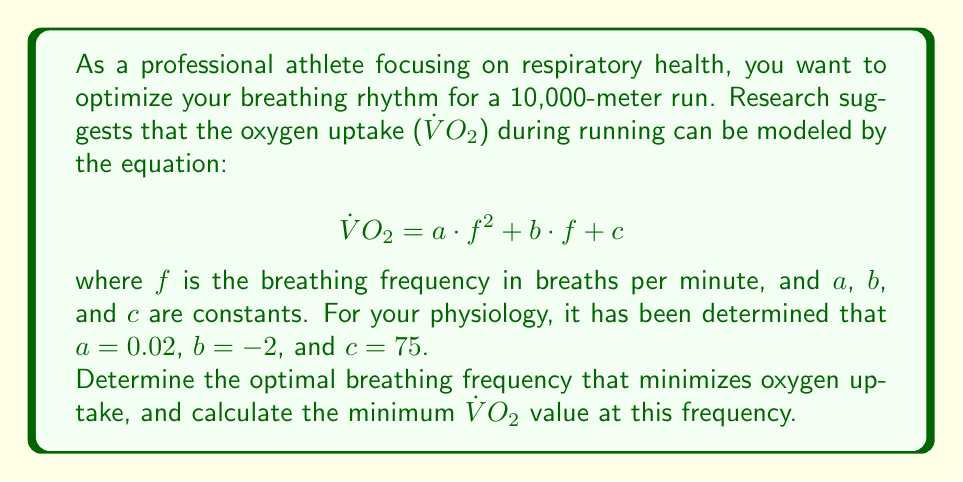Can you answer this question? To solve this optimization problem, we need to follow these steps:

1) The given equation represents a quadratic function:
   $$\dot{V}O_2 = 0.02f^2 - 2f + 75$$

2) To find the minimum of a quadratic function, we need to find the vertex of the parabola. The x-coordinate of the vertex corresponds to the optimal breathing frequency.

3) For a quadratic function in the form $y = ax^2 + bx + c$, the x-coordinate of the vertex is given by:
   $$x = -\frac{b}{2a}$$

4) In our case:
   $$f_{optimal} = -\frac{-2}{2(0.02)} = \frac{2}{0.04} = 50$$

5) To find the minimum $\dot{V}O_2$, we substitute this optimal frequency back into the original equation:

   $$\dot{V}O_2_{min} = 0.02(50)^2 - 2(50) + 75$$
   $$= 0.02(2500) - 100 + 75$$
   $$= 50 - 100 + 75$$
   $$= 25$$

Therefore, the optimal breathing frequency is 50 breaths per minute, and the minimum oxygen uptake at this frequency is 25 mL/kg/min.
Answer: Optimal breathing frequency: 50 breaths per minute
Minimum $\dot{V}O_2$: 25 mL/kg/min 